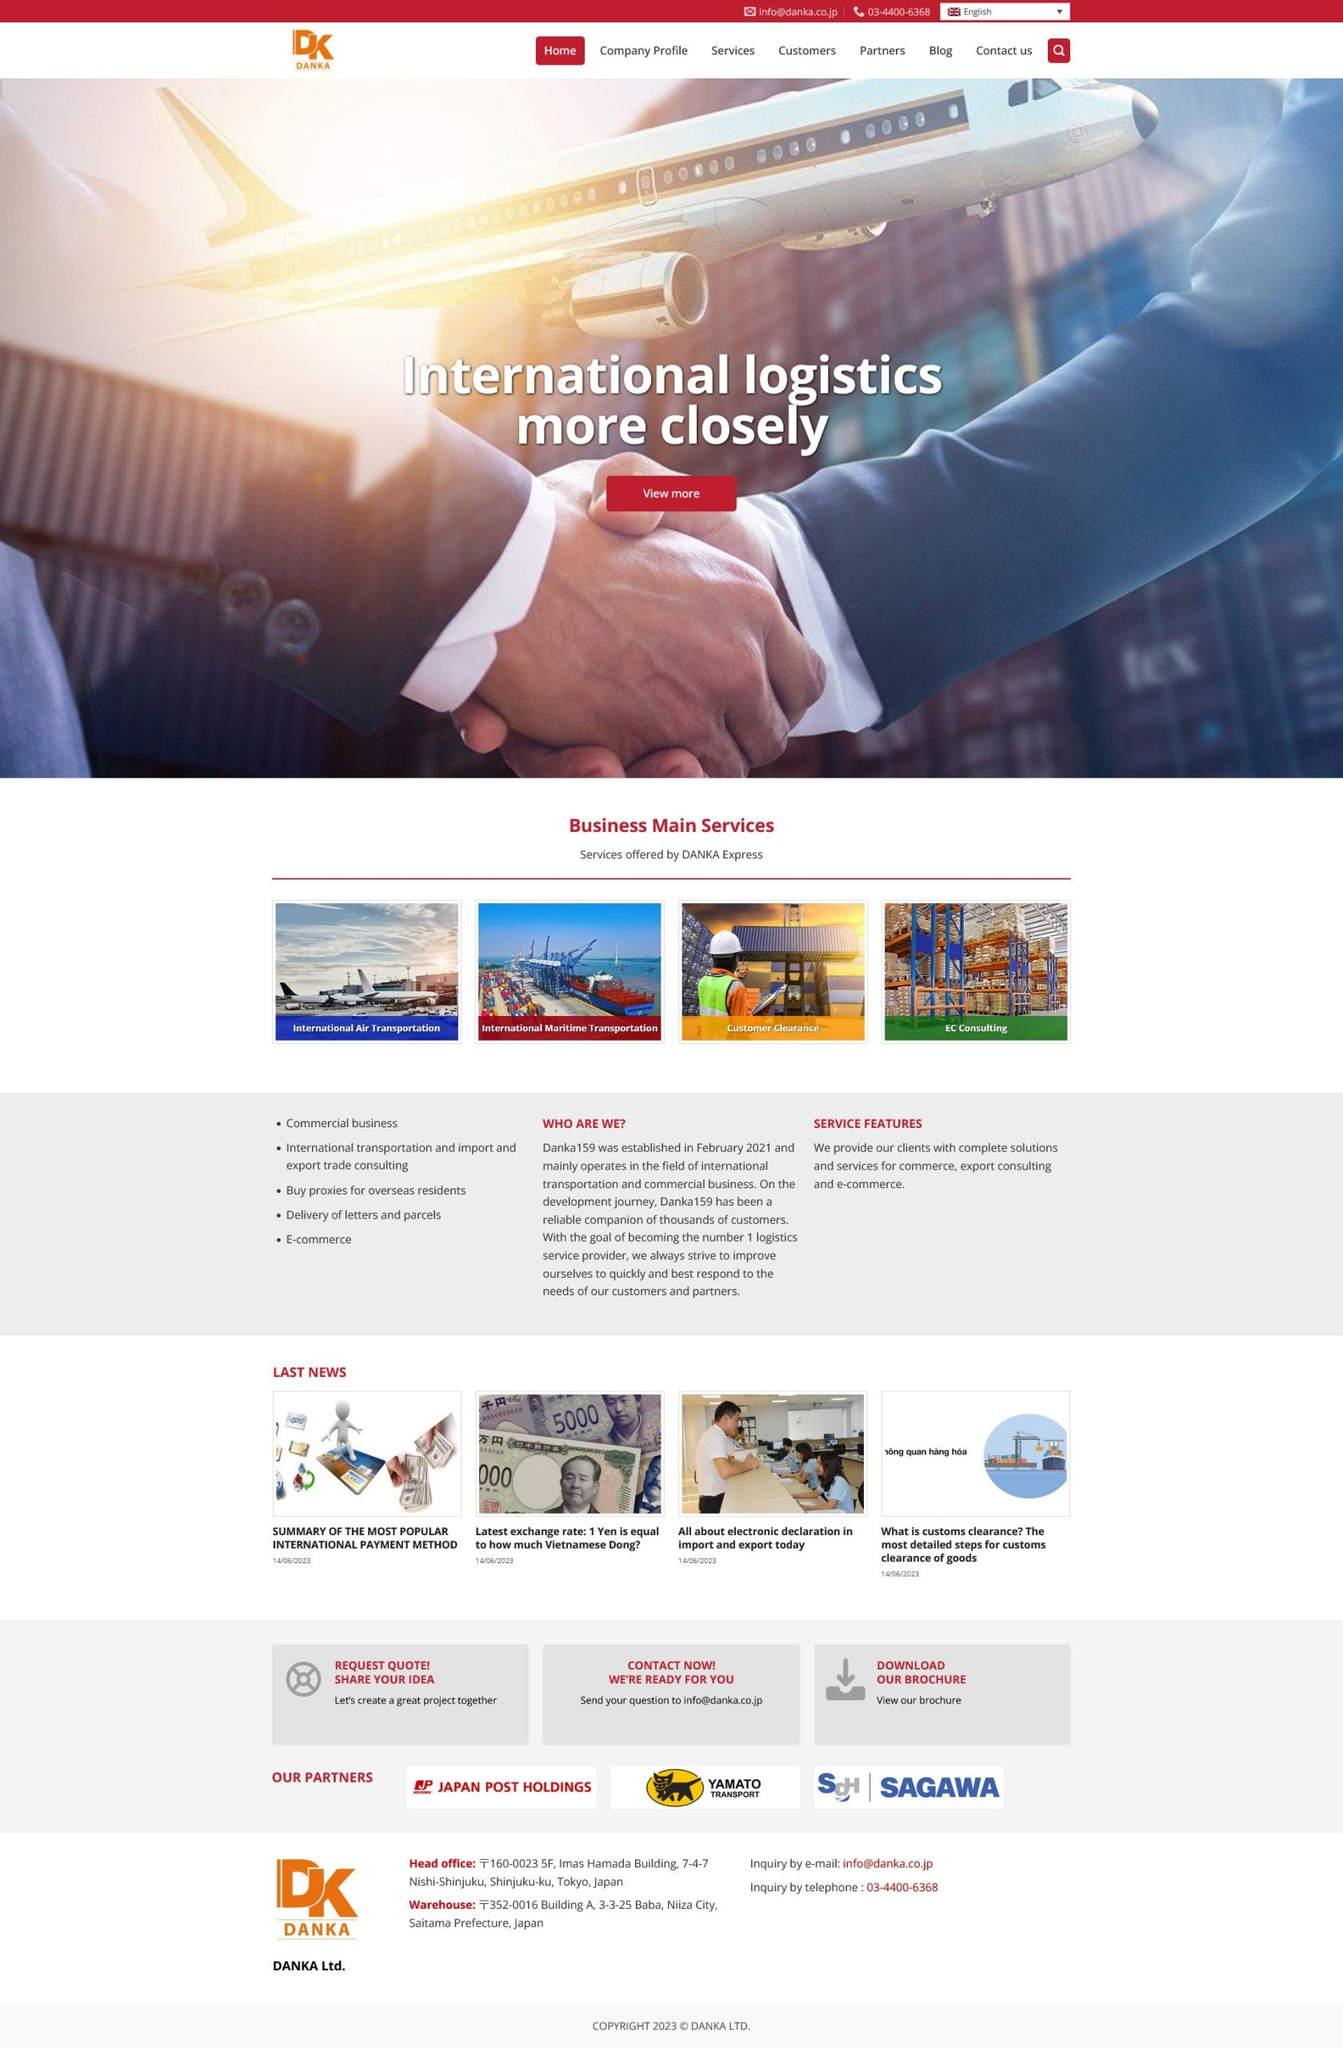Liệt kê 5 ngành nghề, lĩnh vực phù hợp với website này, phân cách các màu sắc bằng dấu phẩy. Chỉ trả về kết quả, phân cách bằng dấy phẩy
 Vận tải quốc tế, Hàng không, Vận tải biển, Thủ tục hải quan, Thương mại điện tử 